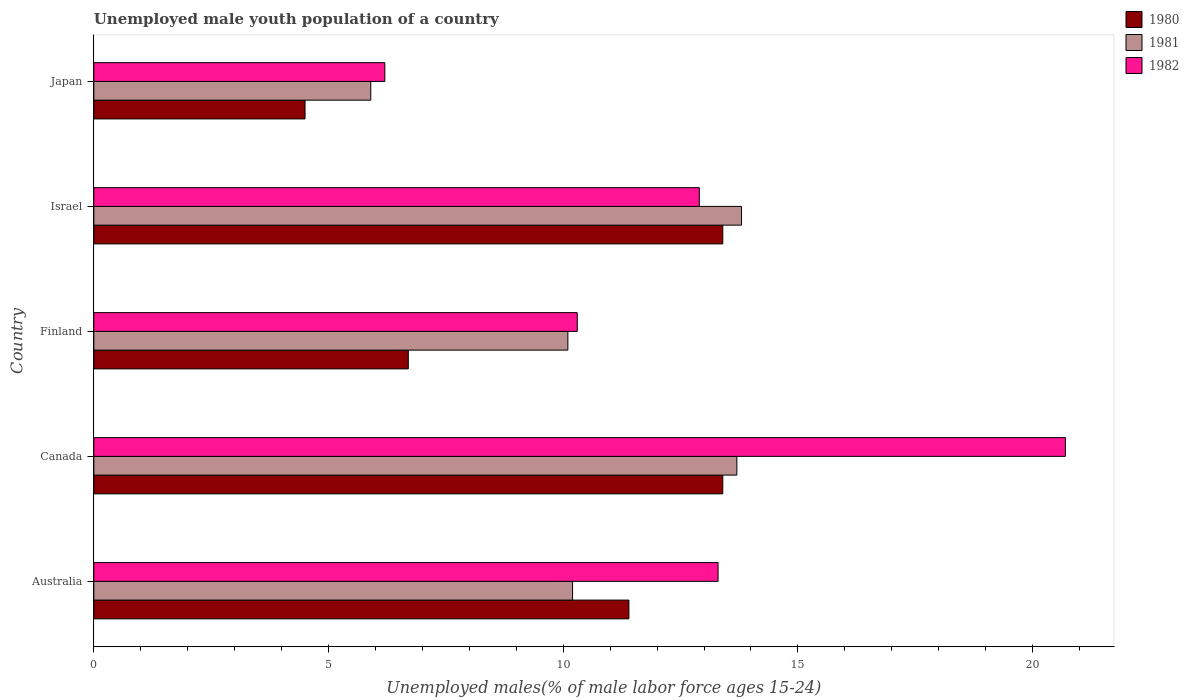How many groups of bars are there?
Ensure brevity in your answer.  5. Are the number of bars on each tick of the Y-axis equal?
Offer a very short reply. Yes. How many bars are there on the 2nd tick from the bottom?
Ensure brevity in your answer.  3. What is the label of the 3rd group of bars from the top?
Offer a very short reply. Finland. What is the percentage of unemployed male youth population in 1981 in Canada?
Make the answer very short. 13.7. Across all countries, what is the maximum percentage of unemployed male youth population in 1980?
Keep it short and to the point. 13.4. Across all countries, what is the minimum percentage of unemployed male youth population in 1981?
Make the answer very short. 5.9. In which country was the percentage of unemployed male youth population in 1980 minimum?
Make the answer very short. Japan. What is the total percentage of unemployed male youth population in 1980 in the graph?
Provide a short and direct response. 49.4. What is the difference between the percentage of unemployed male youth population in 1982 in Canada and that in Finland?
Ensure brevity in your answer.  10.4. What is the difference between the percentage of unemployed male youth population in 1981 in Canada and the percentage of unemployed male youth population in 1982 in Australia?
Offer a terse response. 0.4. What is the average percentage of unemployed male youth population in 1981 per country?
Provide a succinct answer. 10.74. What is the difference between the percentage of unemployed male youth population in 1980 and percentage of unemployed male youth population in 1982 in Canada?
Make the answer very short. -7.3. What is the ratio of the percentage of unemployed male youth population in 1980 in Canada to that in Japan?
Your response must be concise. 2.98. Is the percentage of unemployed male youth population in 1980 in Israel less than that in Japan?
Ensure brevity in your answer.  No. Is the difference between the percentage of unemployed male youth population in 1980 in Finland and Japan greater than the difference between the percentage of unemployed male youth population in 1982 in Finland and Japan?
Give a very brief answer. No. What is the difference between the highest and the second highest percentage of unemployed male youth population in 1981?
Your answer should be compact. 0.1. What is the difference between the highest and the lowest percentage of unemployed male youth population in 1980?
Offer a terse response. 8.9. In how many countries, is the percentage of unemployed male youth population in 1982 greater than the average percentage of unemployed male youth population in 1982 taken over all countries?
Your response must be concise. 3. Is the sum of the percentage of unemployed male youth population in 1981 in Australia and Japan greater than the maximum percentage of unemployed male youth population in 1980 across all countries?
Provide a succinct answer. Yes. What does the 3rd bar from the bottom in Japan represents?
Offer a terse response. 1982. Is it the case that in every country, the sum of the percentage of unemployed male youth population in 1980 and percentage of unemployed male youth population in 1981 is greater than the percentage of unemployed male youth population in 1982?
Your answer should be very brief. Yes. Are all the bars in the graph horizontal?
Provide a succinct answer. Yes. How many countries are there in the graph?
Offer a very short reply. 5. What is the difference between two consecutive major ticks on the X-axis?
Your answer should be compact. 5. Are the values on the major ticks of X-axis written in scientific E-notation?
Offer a very short reply. No. Does the graph contain grids?
Provide a short and direct response. No. What is the title of the graph?
Ensure brevity in your answer.  Unemployed male youth population of a country. What is the label or title of the X-axis?
Your answer should be compact. Unemployed males(% of male labor force ages 15-24). What is the Unemployed males(% of male labor force ages 15-24) of 1980 in Australia?
Offer a very short reply. 11.4. What is the Unemployed males(% of male labor force ages 15-24) in 1981 in Australia?
Your answer should be very brief. 10.2. What is the Unemployed males(% of male labor force ages 15-24) in 1982 in Australia?
Keep it short and to the point. 13.3. What is the Unemployed males(% of male labor force ages 15-24) in 1980 in Canada?
Offer a very short reply. 13.4. What is the Unemployed males(% of male labor force ages 15-24) in 1981 in Canada?
Offer a very short reply. 13.7. What is the Unemployed males(% of male labor force ages 15-24) of 1982 in Canada?
Your response must be concise. 20.7. What is the Unemployed males(% of male labor force ages 15-24) in 1980 in Finland?
Give a very brief answer. 6.7. What is the Unemployed males(% of male labor force ages 15-24) in 1981 in Finland?
Give a very brief answer. 10.1. What is the Unemployed males(% of male labor force ages 15-24) in 1982 in Finland?
Offer a very short reply. 10.3. What is the Unemployed males(% of male labor force ages 15-24) of 1980 in Israel?
Your response must be concise. 13.4. What is the Unemployed males(% of male labor force ages 15-24) in 1981 in Israel?
Keep it short and to the point. 13.8. What is the Unemployed males(% of male labor force ages 15-24) in 1982 in Israel?
Offer a terse response. 12.9. What is the Unemployed males(% of male labor force ages 15-24) in 1981 in Japan?
Provide a short and direct response. 5.9. What is the Unemployed males(% of male labor force ages 15-24) of 1982 in Japan?
Offer a terse response. 6.2. Across all countries, what is the maximum Unemployed males(% of male labor force ages 15-24) of 1980?
Make the answer very short. 13.4. Across all countries, what is the maximum Unemployed males(% of male labor force ages 15-24) of 1981?
Make the answer very short. 13.8. Across all countries, what is the maximum Unemployed males(% of male labor force ages 15-24) in 1982?
Provide a succinct answer. 20.7. Across all countries, what is the minimum Unemployed males(% of male labor force ages 15-24) of 1980?
Give a very brief answer. 4.5. Across all countries, what is the minimum Unemployed males(% of male labor force ages 15-24) of 1981?
Offer a very short reply. 5.9. Across all countries, what is the minimum Unemployed males(% of male labor force ages 15-24) of 1982?
Provide a succinct answer. 6.2. What is the total Unemployed males(% of male labor force ages 15-24) of 1980 in the graph?
Offer a very short reply. 49.4. What is the total Unemployed males(% of male labor force ages 15-24) in 1981 in the graph?
Your response must be concise. 53.7. What is the total Unemployed males(% of male labor force ages 15-24) of 1982 in the graph?
Ensure brevity in your answer.  63.4. What is the difference between the Unemployed males(% of male labor force ages 15-24) of 1981 in Australia and that in Canada?
Keep it short and to the point. -3.5. What is the difference between the Unemployed males(% of male labor force ages 15-24) in 1980 in Australia and that in Israel?
Keep it short and to the point. -2. What is the difference between the Unemployed males(% of male labor force ages 15-24) in 1981 in Australia and that in Israel?
Provide a succinct answer. -3.6. What is the difference between the Unemployed males(% of male labor force ages 15-24) of 1982 in Australia and that in Israel?
Your answer should be very brief. 0.4. What is the difference between the Unemployed males(% of male labor force ages 15-24) in 1981 in Australia and that in Japan?
Your answer should be compact. 4.3. What is the difference between the Unemployed males(% of male labor force ages 15-24) in 1980 in Canada and that in Finland?
Give a very brief answer. 6.7. What is the difference between the Unemployed males(% of male labor force ages 15-24) of 1981 in Canada and that in Japan?
Your answer should be compact. 7.8. What is the difference between the Unemployed males(% of male labor force ages 15-24) of 1981 in Finland and that in Israel?
Give a very brief answer. -3.7. What is the difference between the Unemployed males(% of male labor force ages 15-24) in 1982 in Finland and that in Israel?
Your response must be concise. -2.6. What is the difference between the Unemployed males(% of male labor force ages 15-24) in 1981 in Finland and that in Japan?
Your answer should be compact. 4.2. What is the difference between the Unemployed males(% of male labor force ages 15-24) in 1980 in Israel and that in Japan?
Make the answer very short. 8.9. What is the difference between the Unemployed males(% of male labor force ages 15-24) of 1981 in Israel and that in Japan?
Offer a very short reply. 7.9. What is the difference between the Unemployed males(% of male labor force ages 15-24) in 1982 in Israel and that in Japan?
Provide a short and direct response. 6.7. What is the difference between the Unemployed males(% of male labor force ages 15-24) of 1980 in Australia and the Unemployed males(% of male labor force ages 15-24) of 1981 in Finland?
Your response must be concise. 1.3. What is the difference between the Unemployed males(% of male labor force ages 15-24) of 1980 in Australia and the Unemployed males(% of male labor force ages 15-24) of 1982 in Finland?
Keep it short and to the point. 1.1. What is the difference between the Unemployed males(% of male labor force ages 15-24) in 1980 in Australia and the Unemployed males(% of male labor force ages 15-24) in 1982 in Israel?
Give a very brief answer. -1.5. What is the difference between the Unemployed males(% of male labor force ages 15-24) in 1980 in Australia and the Unemployed males(% of male labor force ages 15-24) in 1982 in Japan?
Give a very brief answer. 5.2. What is the difference between the Unemployed males(% of male labor force ages 15-24) of 1981 in Australia and the Unemployed males(% of male labor force ages 15-24) of 1982 in Japan?
Give a very brief answer. 4. What is the difference between the Unemployed males(% of male labor force ages 15-24) of 1980 in Canada and the Unemployed males(% of male labor force ages 15-24) of 1981 in Finland?
Ensure brevity in your answer.  3.3. What is the difference between the Unemployed males(% of male labor force ages 15-24) in 1980 in Canada and the Unemployed males(% of male labor force ages 15-24) in 1981 in Israel?
Give a very brief answer. -0.4. What is the difference between the Unemployed males(% of male labor force ages 15-24) of 1981 in Canada and the Unemployed males(% of male labor force ages 15-24) of 1982 in Israel?
Your response must be concise. 0.8. What is the difference between the Unemployed males(% of male labor force ages 15-24) of 1980 in Canada and the Unemployed males(% of male labor force ages 15-24) of 1981 in Japan?
Your response must be concise. 7.5. What is the difference between the Unemployed males(% of male labor force ages 15-24) in 1980 in Canada and the Unemployed males(% of male labor force ages 15-24) in 1982 in Japan?
Provide a succinct answer. 7.2. What is the difference between the Unemployed males(% of male labor force ages 15-24) of 1980 in Finland and the Unemployed males(% of male labor force ages 15-24) of 1982 in Israel?
Keep it short and to the point. -6.2. What is the difference between the Unemployed males(% of male labor force ages 15-24) of 1981 in Finland and the Unemployed males(% of male labor force ages 15-24) of 1982 in Israel?
Provide a succinct answer. -2.8. What is the difference between the Unemployed males(% of male labor force ages 15-24) of 1980 in Finland and the Unemployed males(% of male labor force ages 15-24) of 1981 in Japan?
Keep it short and to the point. 0.8. What is the difference between the Unemployed males(% of male labor force ages 15-24) of 1981 in Finland and the Unemployed males(% of male labor force ages 15-24) of 1982 in Japan?
Keep it short and to the point. 3.9. What is the difference between the Unemployed males(% of male labor force ages 15-24) in 1980 in Israel and the Unemployed males(% of male labor force ages 15-24) in 1982 in Japan?
Your response must be concise. 7.2. What is the average Unemployed males(% of male labor force ages 15-24) in 1980 per country?
Offer a terse response. 9.88. What is the average Unemployed males(% of male labor force ages 15-24) in 1981 per country?
Provide a succinct answer. 10.74. What is the average Unemployed males(% of male labor force ages 15-24) of 1982 per country?
Offer a very short reply. 12.68. What is the difference between the Unemployed males(% of male labor force ages 15-24) in 1981 and Unemployed males(% of male labor force ages 15-24) in 1982 in Australia?
Ensure brevity in your answer.  -3.1. What is the difference between the Unemployed males(% of male labor force ages 15-24) in 1981 and Unemployed males(% of male labor force ages 15-24) in 1982 in Canada?
Offer a very short reply. -7. What is the difference between the Unemployed males(% of male labor force ages 15-24) in 1980 and Unemployed males(% of male labor force ages 15-24) in 1981 in Israel?
Your answer should be very brief. -0.4. What is the difference between the Unemployed males(% of male labor force ages 15-24) of 1981 and Unemployed males(% of male labor force ages 15-24) of 1982 in Israel?
Ensure brevity in your answer.  0.9. What is the difference between the Unemployed males(% of male labor force ages 15-24) of 1980 and Unemployed males(% of male labor force ages 15-24) of 1981 in Japan?
Keep it short and to the point. -1.4. What is the difference between the Unemployed males(% of male labor force ages 15-24) of 1980 and Unemployed males(% of male labor force ages 15-24) of 1982 in Japan?
Make the answer very short. -1.7. What is the difference between the Unemployed males(% of male labor force ages 15-24) in 1981 and Unemployed males(% of male labor force ages 15-24) in 1982 in Japan?
Your answer should be compact. -0.3. What is the ratio of the Unemployed males(% of male labor force ages 15-24) of 1980 in Australia to that in Canada?
Offer a very short reply. 0.85. What is the ratio of the Unemployed males(% of male labor force ages 15-24) in 1981 in Australia to that in Canada?
Keep it short and to the point. 0.74. What is the ratio of the Unemployed males(% of male labor force ages 15-24) in 1982 in Australia to that in Canada?
Ensure brevity in your answer.  0.64. What is the ratio of the Unemployed males(% of male labor force ages 15-24) of 1980 in Australia to that in Finland?
Your response must be concise. 1.7. What is the ratio of the Unemployed males(% of male labor force ages 15-24) in 1981 in Australia to that in Finland?
Offer a terse response. 1.01. What is the ratio of the Unemployed males(% of male labor force ages 15-24) in 1982 in Australia to that in Finland?
Provide a short and direct response. 1.29. What is the ratio of the Unemployed males(% of male labor force ages 15-24) of 1980 in Australia to that in Israel?
Ensure brevity in your answer.  0.85. What is the ratio of the Unemployed males(% of male labor force ages 15-24) in 1981 in Australia to that in Israel?
Offer a very short reply. 0.74. What is the ratio of the Unemployed males(% of male labor force ages 15-24) of 1982 in Australia to that in Israel?
Your response must be concise. 1.03. What is the ratio of the Unemployed males(% of male labor force ages 15-24) in 1980 in Australia to that in Japan?
Your answer should be very brief. 2.53. What is the ratio of the Unemployed males(% of male labor force ages 15-24) of 1981 in Australia to that in Japan?
Make the answer very short. 1.73. What is the ratio of the Unemployed males(% of male labor force ages 15-24) of 1982 in Australia to that in Japan?
Your answer should be very brief. 2.15. What is the ratio of the Unemployed males(% of male labor force ages 15-24) of 1981 in Canada to that in Finland?
Provide a succinct answer. 1.36. What is the ratio of the Unemployed males(% of male labor force ages 15-24) in 1982 in Canada to that in Finland?
Give a very brief answer. 2.01. What is the ratio of the Unemployed males(% of male labor force ages 15-24) of 1981 in Canada to that in Israel?
Offer a very short reply. 0.99. What is the ratio of the Unemployed males(% of male labor force ages 15-24) in 1982 in Canada to that in Israel?
Offer a terse response. 1.6. What is the ratio of the Unemployed males(% of male labor force ages 15-24) of 1980 in Canada to that in Japan?
Provide a short and direct response. 2.98. What is the ratio of the Unemployed males(% of male labor force ages 15-24) in 1981 in Canada to that in Japan?
Offer a terse response. 2.32. What is the ratio of the Unemployed males(% of male labor force ages 15-24) in 1982 in Canada to that in Japan?
Make the answer very short. 3.34. What is the ratio of the Unemployed males(% of male labor force ages 15-24) in 1980 in Finland to that in Israel?
Your answer should be very brief. 0.5. What is the ratio of the Unemployed males(% of male labor force ages 15-24) in 1981 in Finland to that in Israel?
Provide a succinct answer. 0.73. What is the ratio of the Unemployed males(% of male labor force ages 15-24) in 1982 in Finland to that in Israel?
Your response must be concise. 0.8. What is the ratio of the Unemployed males(% of male labor force ages 15-24) of 1980 in Finland to that in Japan?
Give a very brief answer. 1.49. What is the ratio of the Unemployed males(% of male labor force ages 15-24) of 1981 in Finland to that in Japan?
Your answer should be very brief. 1.71. What is the ratio of the Unemployed males(% of male labor force ages 15-24) of 1982 in Finland to that in Japan?
Ensure brevity in your answer.  1.66. What is the ratio of the Unemployed males(% of male labor force ages 15-24) of 1980 in Israel to that in Japan?
Your answer should be very brief. 2.98. What is the ratio of the Unemployed males(% of male labor force ages 15-24) of 1981 in Israel to that in Japan?
Your answer should be very brief. 2.34. What is the ratio of the Unemployed males(% of male labor force ages 15-24) in 1982 in Israel to that in Japan?
Ensure brevity in your answer.  2.08. What is the difference between the highest and the second highest Unemployed males(% of male labor force ages 15-24) in 1981?
Your answer should be compact. 0.1. What is the difference between the highest and the lowest Unemployed males(% of male labor force ages 15-24) of 1980?
Offer a terse response. 8.9. 